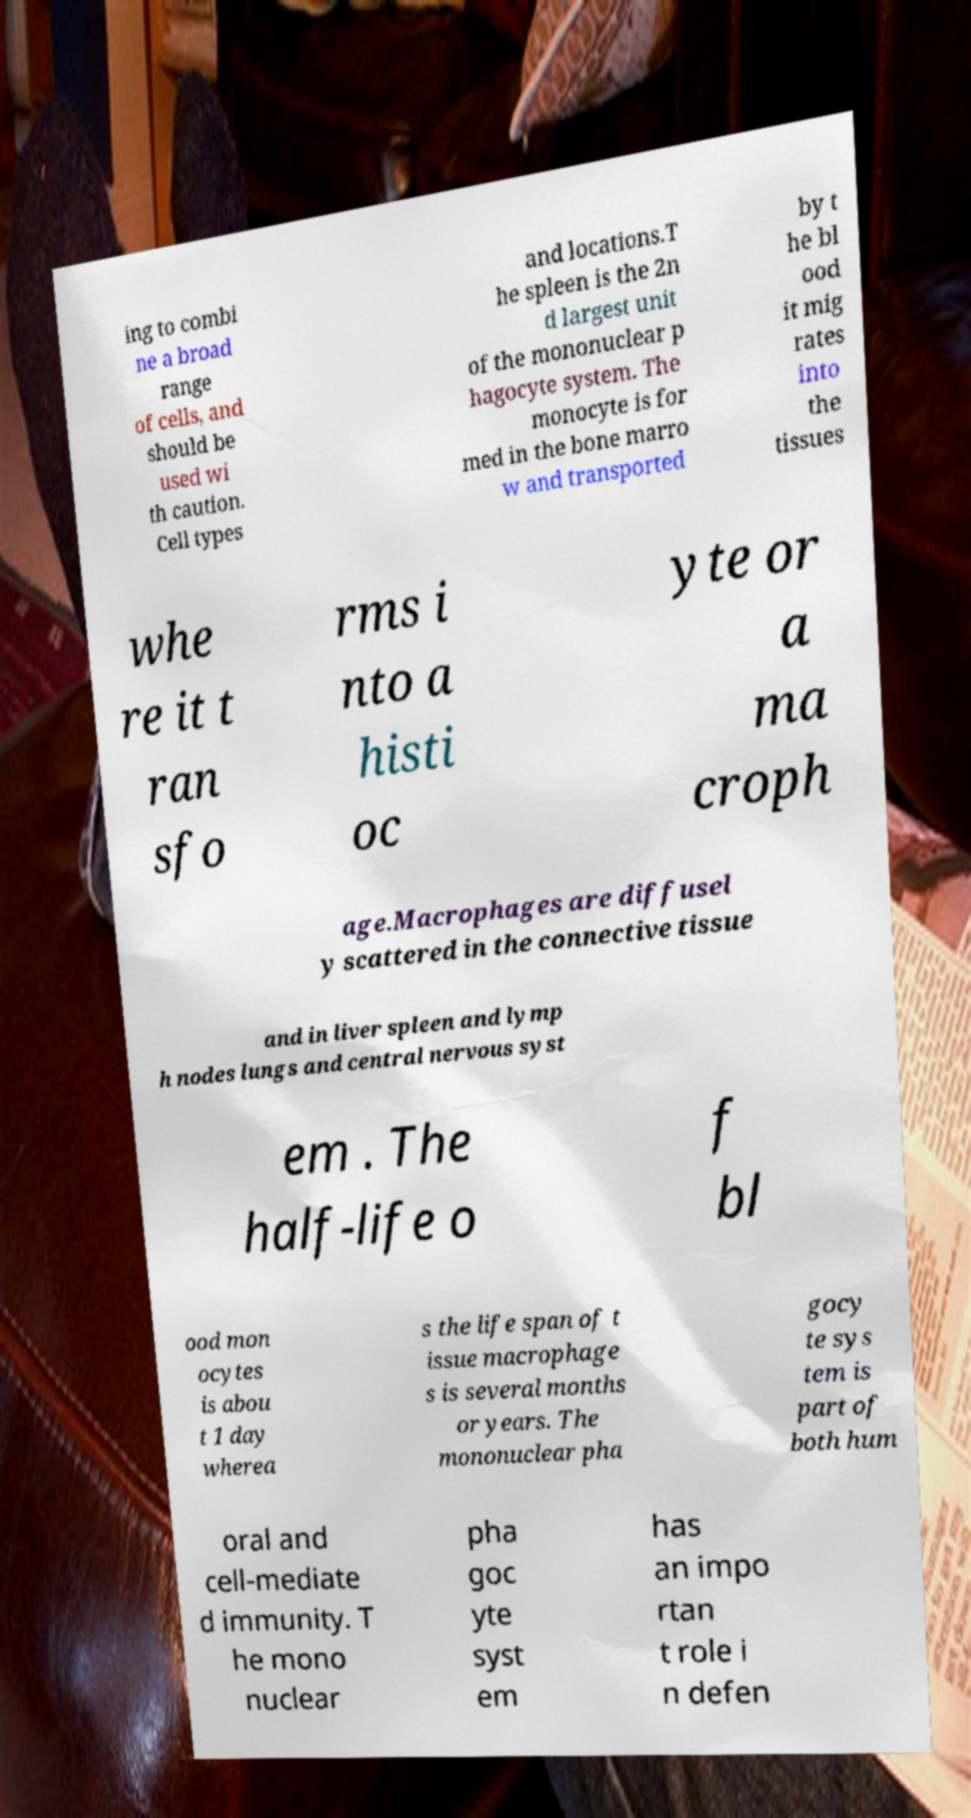What messages or text are displayed in this image? I need them in a readable, typed format. ing to combi ne a broad range of cells, and should be used wi th caution. Cell types and locations.T he spleen is the 2n d largest unit of the mononuclear p hagocyte system. The monocyte is for med in the bone marro w and transported by t he bl ood it mig rates into the tissues whe re it t ran sfo rms i nto a histi oc yte or a ma croph age.Macrophages are diffusel y scattered in the connective tissue and in liver spleen and lymp h nodes lungs and central nervous syst em . The half-life o f bl ood mon ocytes is abou t 1 day wherea s the life span of t issue macrophage s is several months or years. The mononuclear pha gocy te sys tem is part of both hum oral and cell-mediate d immunity. T he mono nuclear pha goc yte syst em has an impo rtan t role i n defen 